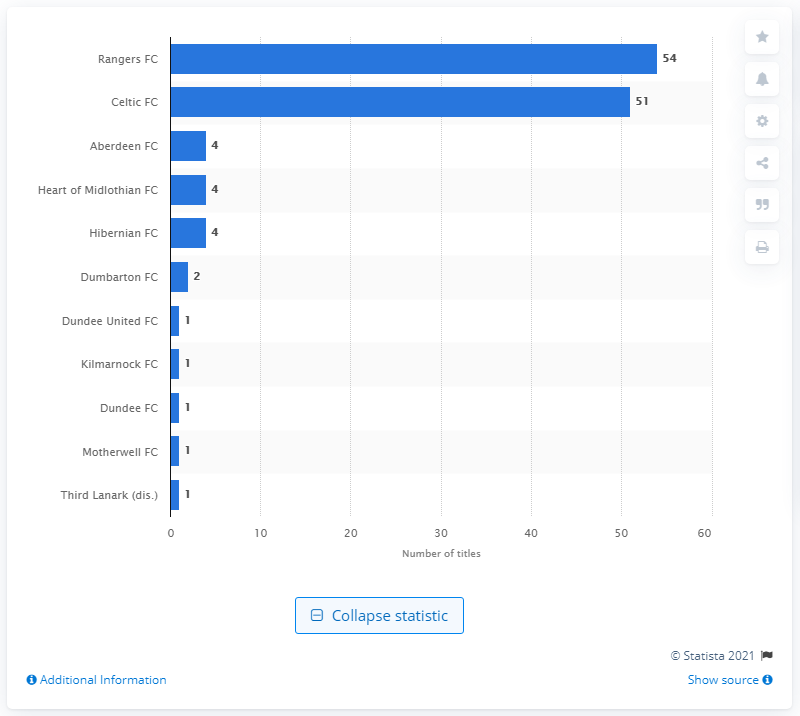List a handful of essential elements in this visual. As of 2020, Rangers FC has won 54 titles. 